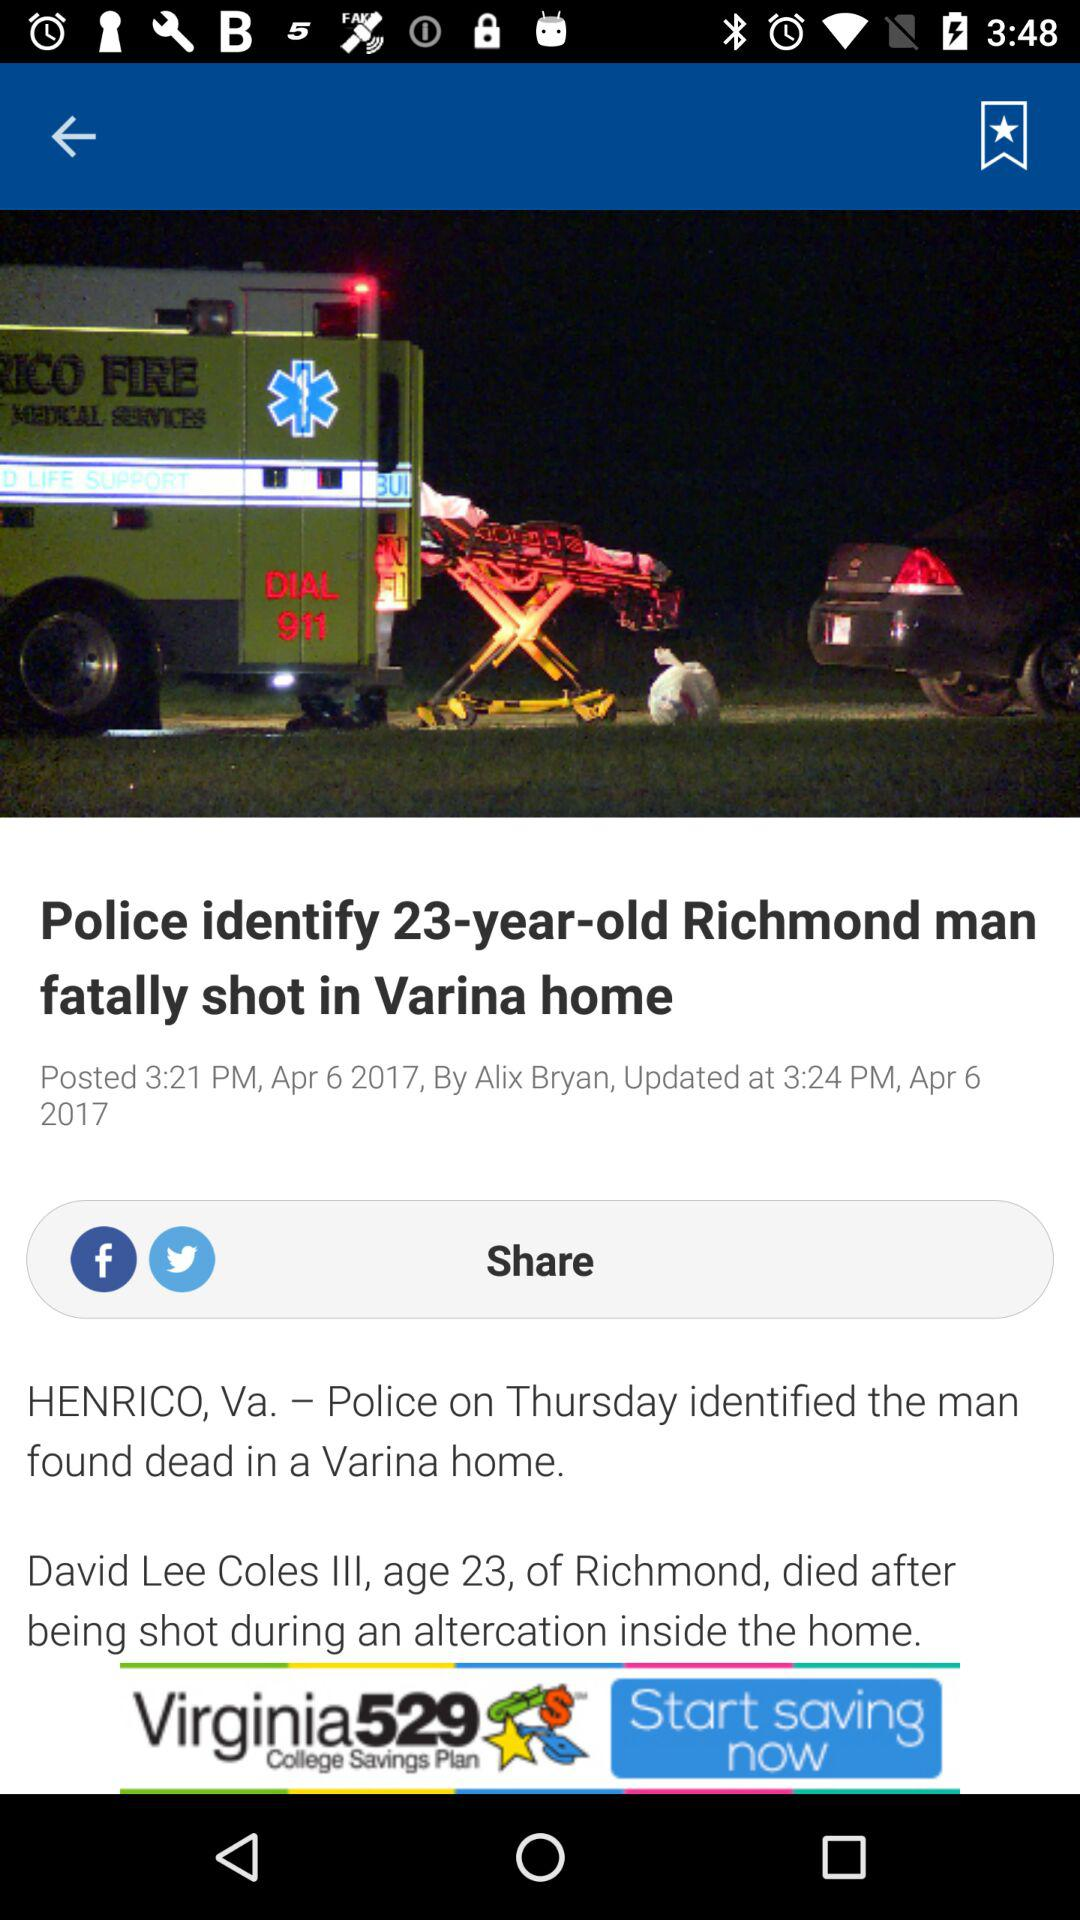Who posted the news about the police identifying a 23-year-old Richmond man fatally shot in Varina home? The news was posted by Alix Bryan. 